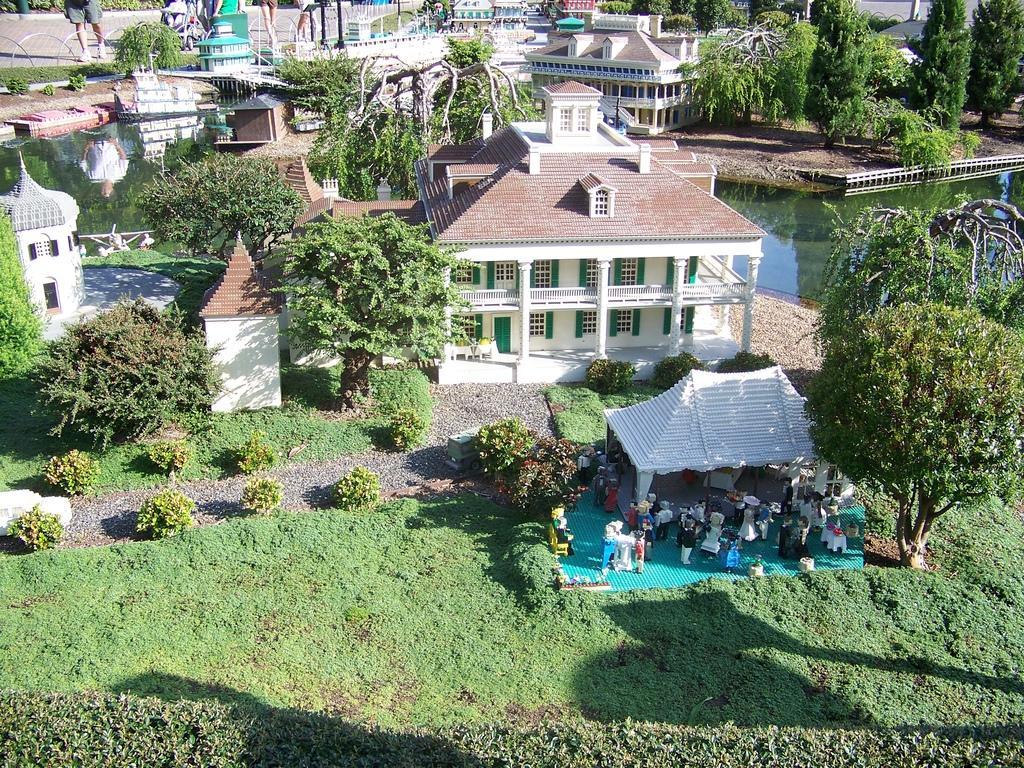Please provide a concise description of this image. There are persons gathered on the floor, which is covered with a carpet, near a shelter, plants and tree on the ground. Beside them, there is grass and plants on the ground. In the background, there are trees, buildings, a lake and persons standing on the road. 